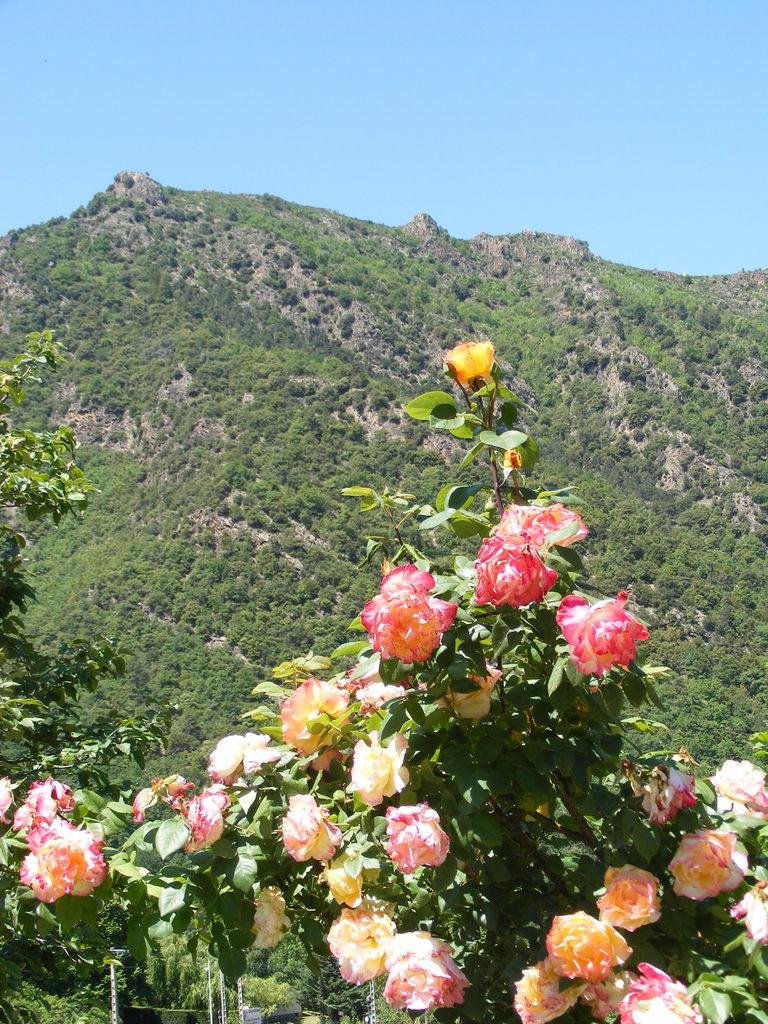What is located in the center of the image? There are flowers and trees in the center of the image. Can you describe the landscape in the center of the image? The center of the image features a combination of flowers and trees. What can be seen in the background of the image? Hills, trees, and the sky are visible in the background of the image. How many different types of natural elements are present in the image? There are at least four different types of natural elements present in the image: flowers, trees, hills, and the sky. What type of bomb can be seen exploding in the image? There is no bomb present in the image; it features flowers, trees, hills, and the sky. What type of dinner is being served in the image? There is no dinner present in the image; it features flowers, trees, hills, and the sky. 